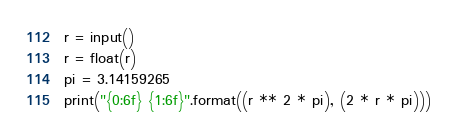<code> <loc_0><loc_0><loc_500><loc_500><_Python_>r = input()
r = float(r)
pi = 3.14159265
print("{0:6f} {1:6f}".format((r ** 2 * pi), (2 * r * pi)))</code> 